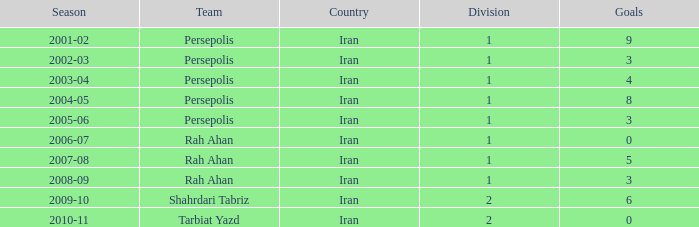What is Season, when Goals is less than 6, and when Team is "Tarbiat Yazd"? 2010-11. Parse the table in full. {'header': ['Season', 'Team', 'Country', 'Division', 'Goals'], 'rows': [['2001-02', 'Persepolis', 'Iran', '1', '9'], ['2002-03', 'Persepolis', 'Iran', '1', '3'], ['2003-04', 'Persepolis', 'Iran', '1', '4'], ['2004-05', 'Persepolis', 'Iran', '1', '8'], ['2005-06', 'Persepolis', 'Iran', '1', '3'], ['2006-07', 'Rah Ahan', 'Iran', '1', '0'], ['2007-08', 'Rah Ahan', 'Iran', '1', '5'], ['2008-09', 'Rah Ahan', 'Iran', '1', '3'], ['2009-10', 'Shahrdari Tabriz', 'Iran', '2', '6'], ['2010-11', 'Tarbiat Yazd', 'Iran', '2', '0']]} 